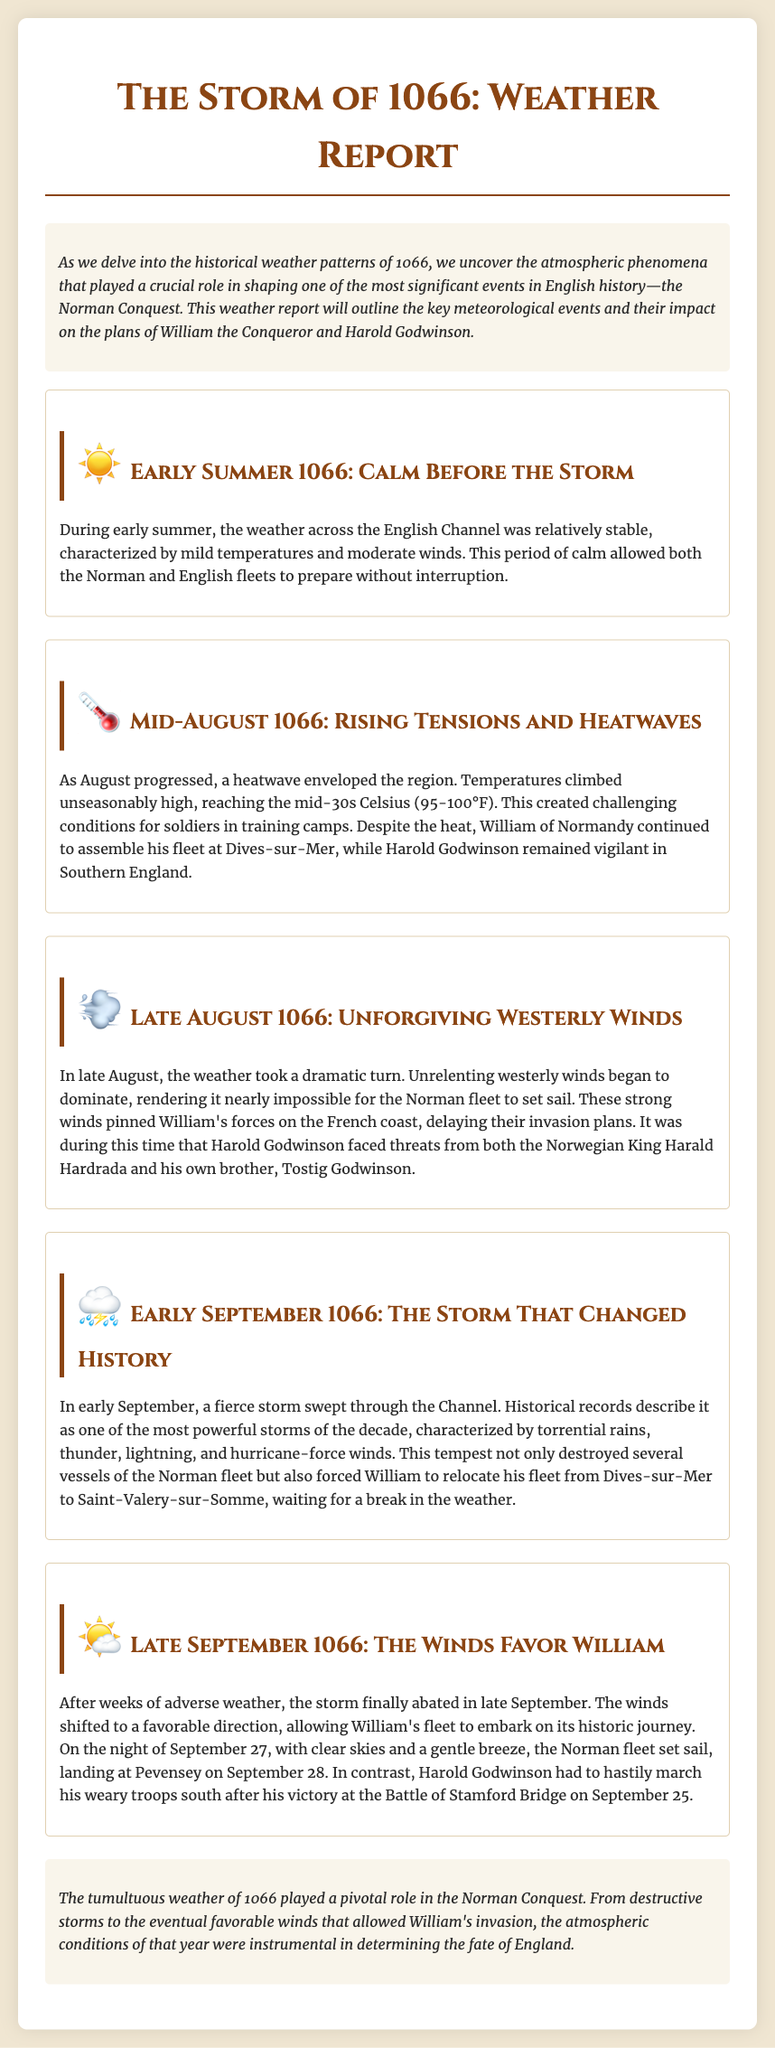What was the temperature during the heatwave in August? The document states that temperatures climbed unseasonably high, reaching the mid-30s Celsius (95-100°F).
Answer: mid-30s Celsius What significant weather event occurred in early September 1066? The document describes a fierce storm characterized by torrential rains, thunder, lightning, and hurricane-force winds.
Answer: a fierce storm Where did William relocate his fleet due to the storm? The report mentions that William had to relocate his fleet from Dives-sur-Mer to Saint-Valery-sur-Somme because of the storm.
Answer: Saint-Valery-sur-Somme When did the Norman fleet set sail? According to the document, the Norman fleet set sail on the night of September 27.
Answer: September 27 What was the impact of the westerly winds in late August? The document states that the strong westerly winds rendered it nearly impossible for the Norman fleet to set sail, delaying their invasion plans.
Answer: delayed invasion plans How did the weather affect Harold Godwinson after September 25? The document indicates that Harold Godwinson had to hastily march his weary troops south after his victory at the Battle of Stamford Bridge on September 25 due to the changing weather conditions.
Answer: hastily march south What type of historical event is the document discussing? The primary focus of the document is the weather patterns leading up to an important historical military event - the Norman Conquest of England.
Answer: the Norman Conquest What was the weather like in early summer 1066? The report describes the weather in early summer as relatively stable, characterized by mild temperatures and moderate winds.
Answer: relatively stable 